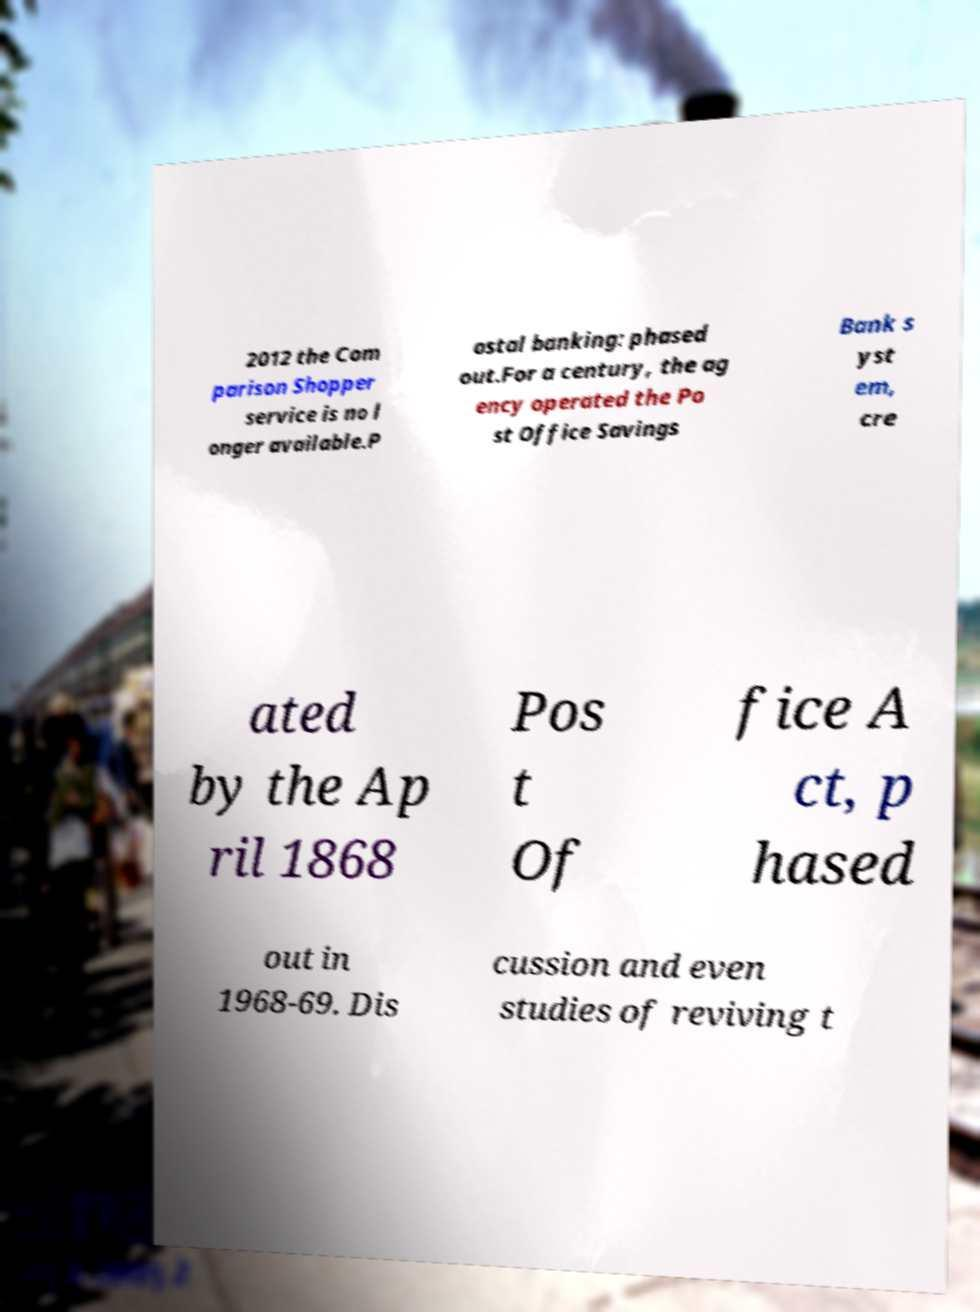Could you extract and type out the text from this image? 2012 the Com parison Shopper service is no l onger available.P ostal banking: phased out.For a century, the ag ency operated the Po st Office Savings Bank s yst em, cre ated by the Ap ril 1868 Pos t Of fice A ct, p hased out in 1968-69. Dis cussion and even studies of reviving t 